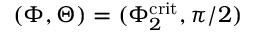<formula> <loc_0><loc_0><loc_500><loc_500>( \Phi , \Theta ) = ( \Phi _ { 2 } ^ { c r i t } , \pi / 2 )</formula> 